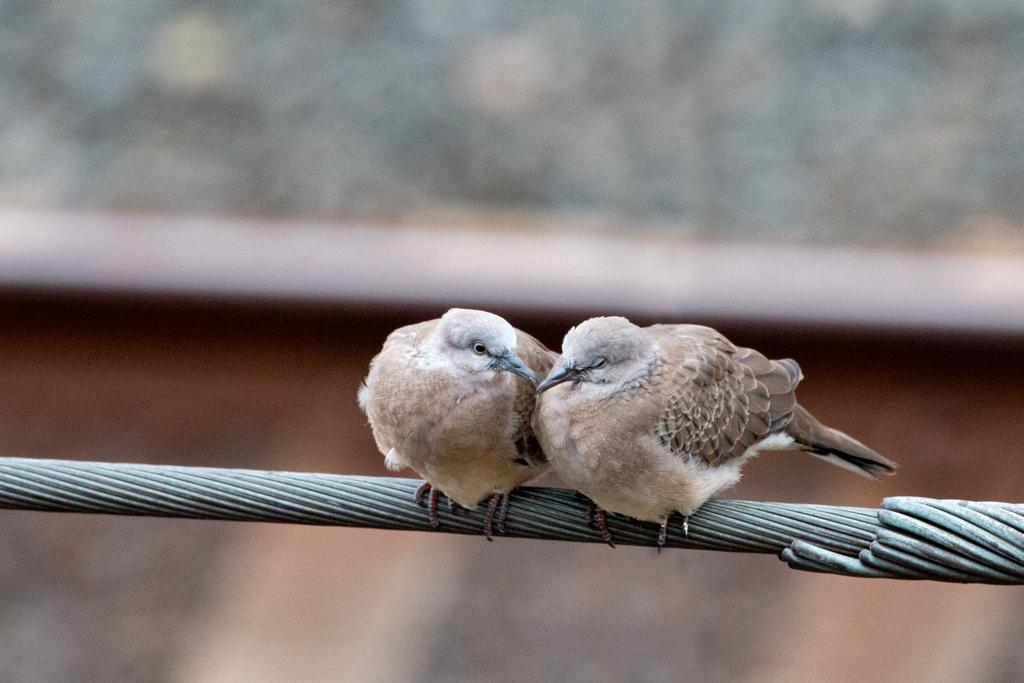How many birds are present in the image? There are two birds in the image. What colors can be seen on the birds? The birds are brown, black, and cream in color. Where are the birds located in the image? The birds are on a wire. Can you describe the background of the image? The background of the image is blurry. How many goats are present in the image? There are no goats present in the image; it features two birds on a wire. What type of cough is the bird experiencing in the image? There is no indication in the image that the bird is experiencing a cough, as birds do not have the ability to cough. 